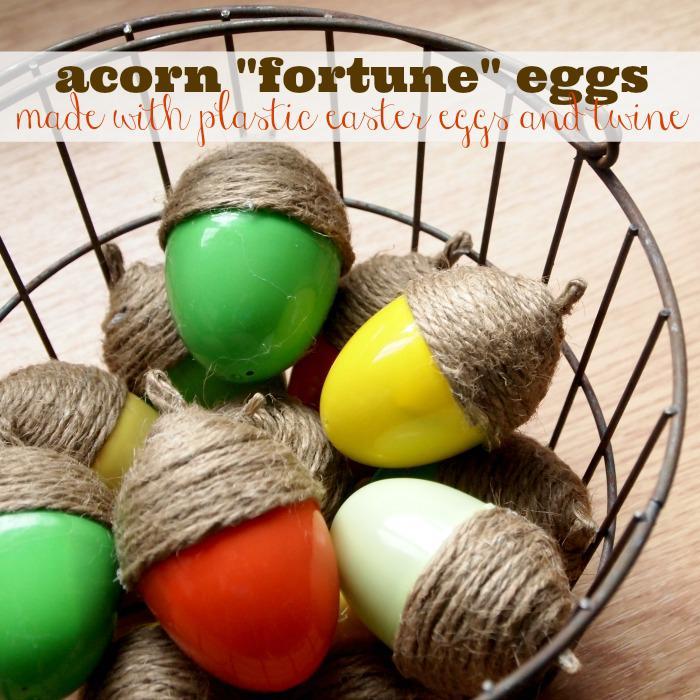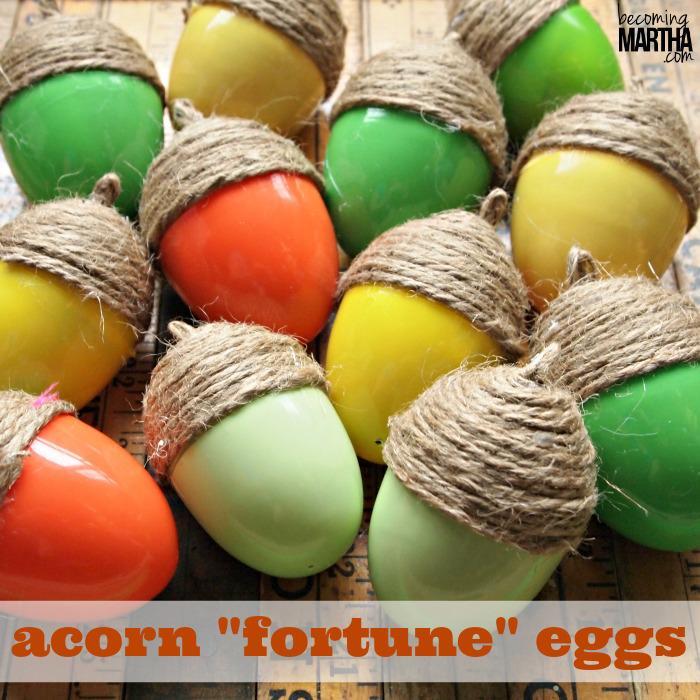The first image is the image on the left, the second image is the image on the right. Assess this claim about the two images: "Each image shows acorn caps made of wrapped twine, and at least one image includes acorns made of plastic eggs in orange, yellow and green colors.". Correct or not? Answer yes or no. Yes. The first image is the image on the left, the second image is the image on the right. Analyze the images presented: Is the assertion "Nothing is edible." valid? Answer yes or no. Yes. 